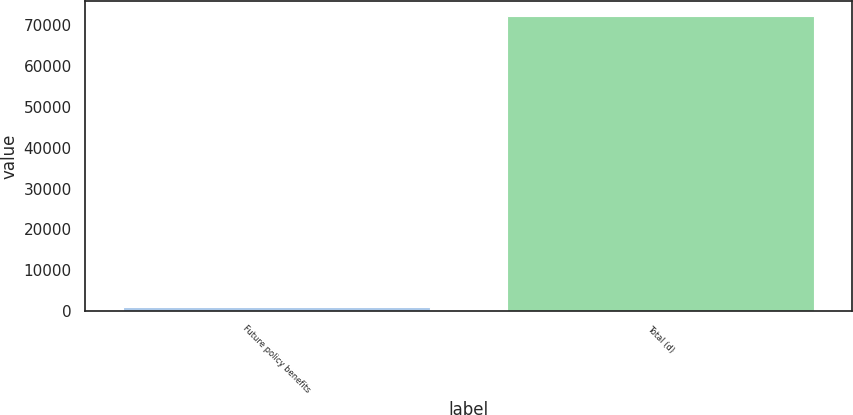<chart> <loc_0><loc_0><loc_500><loc_500><bar_chart><fcel>Future policy benefits<fcel>Total (d)<nl><fcel>893<fcel>72319<nl></chart> 